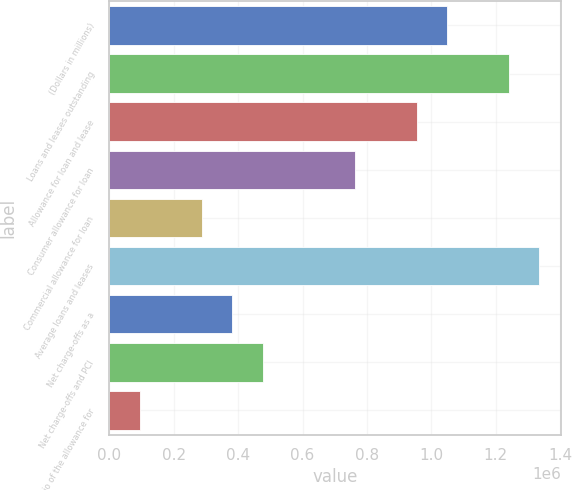Convert chart to OTSL. <chart><loc_0><loc_0><loc_500><loc_500><bar_chart><fcel>(Dollars in millions)<fcel>Loans and leases outstanding<fcel>Allowance for loan and lease<fcel>Consumer allowance for loan<fcel>Commercial allowance for loan<fcel>Average loans and leases<fcel>Net charge-offs as a<fcel>Net charge-offs and PCI<fcel>Ratio of the allowance for<nl><fcel>1.04971e+06<fcel>1.24056e+06<fcel>954278<fcel>763423<fcel>286284<fcel>1.33599e+06<fcel>381712<fcel>477140<fcel>95428.7<nl></chart> 